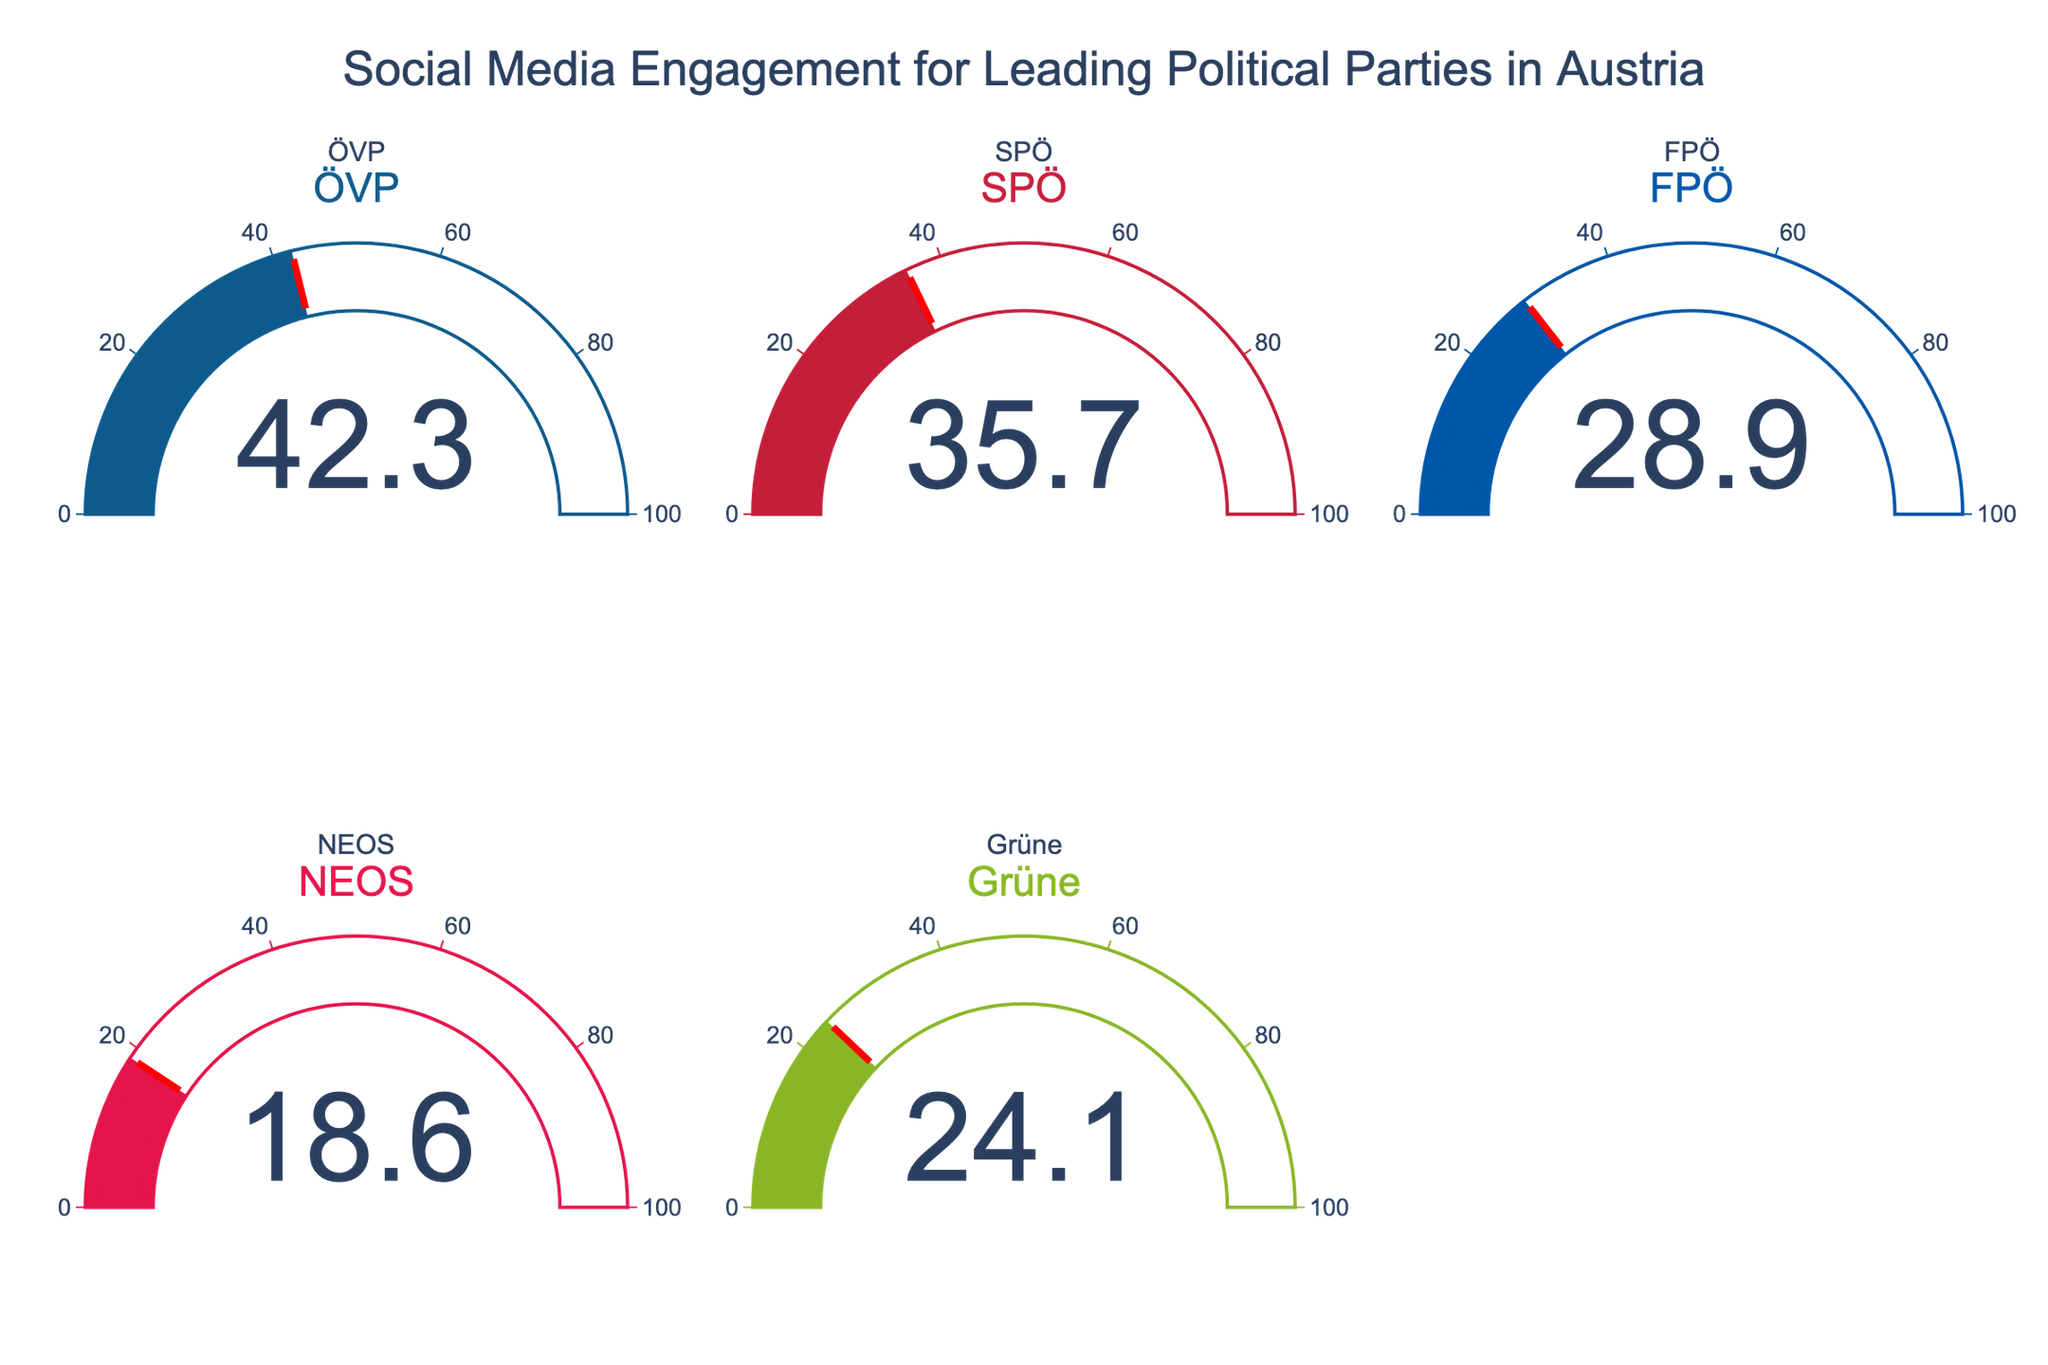What is the social media engagement percentage of the leading political party? The title of the gauge chart indicates it's about social media engagement for leading political parties in Austria. Each gauge displays a percentage representing each party's share of engagement. The gauge for ÖVP shows the highest value.
Answer: 42.3 How many political parties' social media engagement percentages are displayed in the figure? The figure contains one gauge for each political party, and each gauge is labeled with the party's name and engagement percentage. There are gauges labeled ÖVP, SPÖ, FPÖ, NEOS, and Grüne.
Answer: 5 Which political party has the lowest social media engagement? By examining the gauges, each showing a different value, we can find that the NEOS gauge shows the lowest value among the parties.
Answer: NEOS What is the difference in social media engagement between ÖVP and SPÖ? The gauge for ÖVP displays 42.3%, and the gauge for SPÖ shows 35.7%. Subtracting SPÖ's value from ÖVP's gives 42.3 - 35.7.
Answer: 6.6 What is the average social media engagement of all the political parties displayed? To find the average, add all the engagement values (42.3 + 35.7 + 28.9 + 18.6 + 24.1) and divide by the number of parties (5). The sum is 149.6, so the average is 149.6 / 5.
Answer: 29.92 Which two parties combined have a social media engagement close to that of ÖVP? ÖVP's engagement is 42.3%. The closest sum to this value is SPÖ (35.7%) and NEOS (18.6%), totaling 35.7 + 18.6 = 54.3. However, the closest value under 42.3% is FPÖ (28.9%) and Grüne (24.1%), totaling 28.9 + 24.1 = 53.
Answer: FPÖ and Grüne How much higher is NEOS's social media engagement compared to FPÖ's? The gauge for NEOS shows 18.6%, and the gauge for FPÖ shows 28.9%. Subtract NEOS's engagement from FPÖ's value to find the difference, 28.9 - 18.6.
Answer: 10.3 What is the range of social media engagement values among the political parties? Identifying the highest value (42.3% for ÖVP) and the lowest value (18.6% for NEOS) from the gauges, we subtract the lowest from the highest to get the range (42.3 - 18.6).
Answer: 23.7 What is the median social media engagement value of the political parties displayed? Arranging the engagement values in ascending order (18.6, 24.1, 28.9, 35.7, 42.3), the middle value is the third one, which is 28.9.
Answer: 28.9 